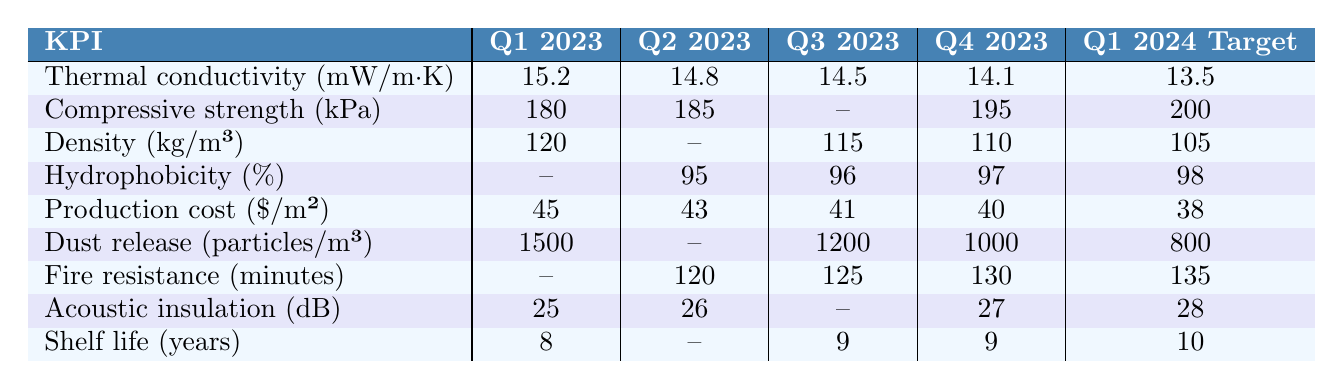What was the thermal conductivity in Q4 2023? The table shows that the thermal conductivity value for Q4 2023 is 14.1 mW/m·K.
Answer: 14.1 mW/m·K What is the production cost target for Q1 2024? According to the table, the production cost target for Q1 2024 is $38 per m².
Answer: $38 How much did the compressive strength increase from Q1 2023 to Q4 2023? The compressive strength for Q1 2023 was 180 kPa and for Q4 2023 it was 195 kPa. The increase is 195 - 180 = 15 kPa.
Answer: 15 kPa What is the average density across all provided quarters? The density values available are 120 (Q1), 115 (Q3), 110 (Q4), giving an average of (120 + 115 + 110) / 3 = 115 kg/m³. Q2 has no value, so it's not included in this calculation.
Answer: 115 kg/m³ Is there a trend showing improvement in hydrophobicity from Q2 2023 to Q1 2024? The hydrophobicity values are 95% in Q2, 96% in Q3, 97% in Q4, and target 98% in Q1 2024, indicating consistent improvement in hydrophobicity over the period.
Answer: Yes What is the reduction in dust release from Q1 2023 to the Q1 2024 target? Dust release value was 1500 particles/m³ in Q1 2023 and the target for Q1 2024 is 800 particles/m³. The reduction is 1500 - 800 = 700 particles/m³.
Answer: 700 particles/m³ In which quarter was there the highest recorded acoustic insulation value? The table indicates that the highest acoustic insulation value is 27 dB in Q4 2023.
Answer: Q4 2023 What is the difference in fire resistance between Q1 2024 target and Q2 2023? The fire resistance in Q2 2023 is 120 minutes, and the Q1 2024 target is 135 minutes. The difference is 135 - 120 = 15 minutes.
Answer: 15 minutes Did the shelf life improve from Q1 2023 to Q1 2024? The shelf life increased from 8 years in Q1 2023 to a target of 10 years in Q1 2024, showing an improvement.
Answer: Yes What is the overall trend in production cost from Q1 2023 to Q1 2024? The production cost decreased from $45 in Q1 2023 to the target of $38 in Q1 2024, therefore showing a downward trend.
Answer: Downward trend 